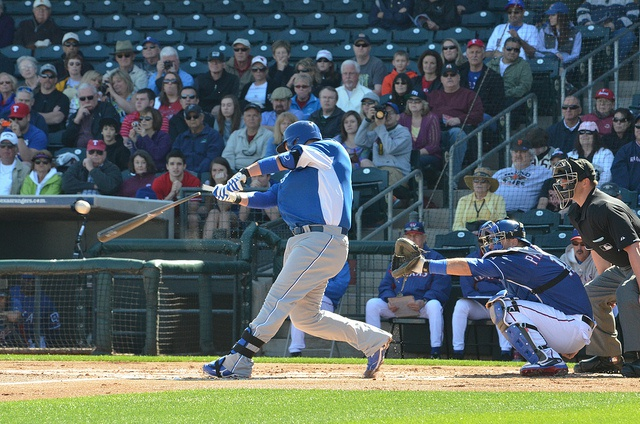Describe the objects in this image and their specific colors. I can see people in blue, black, gray, and navy tones, people in blue, darkgray, lightgray, and gray tones, chair in blue, darkblue, navy, and gray tones, people in blue, navy, lavender, black, and gray tones, and people in blue, black, gray, and darkgray tones in this image. 